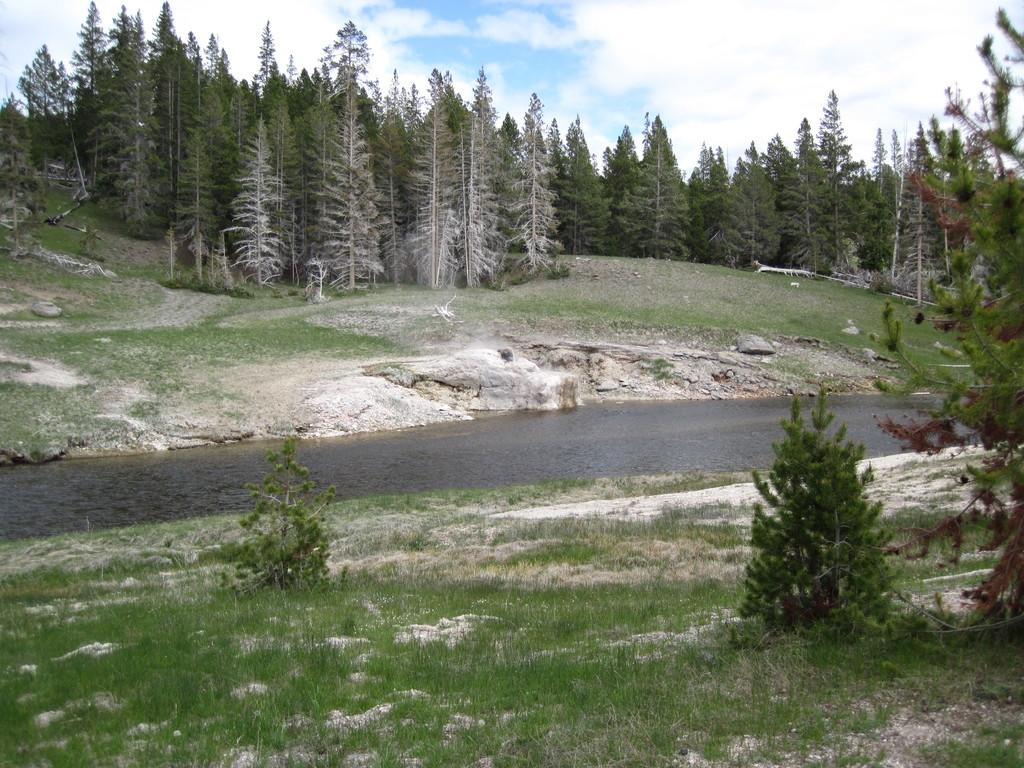What type of terrain is visible in the foreground of the image? There is grassland in the foreground of the image. What can be found on the grassland? There are trees on the grassland. What natural feature is flowing through the middle of the image? There is a river flowing in the middle of the image. What is visible in the background of the image? There are trees and the sky in the background of the image. What can be seen in the sky? There are clouds in the sky. Where is the throne located in the image? There is no throne present in the image. What type of stone can be seen in the river in the image? There is no stone visible in the river in the image. 